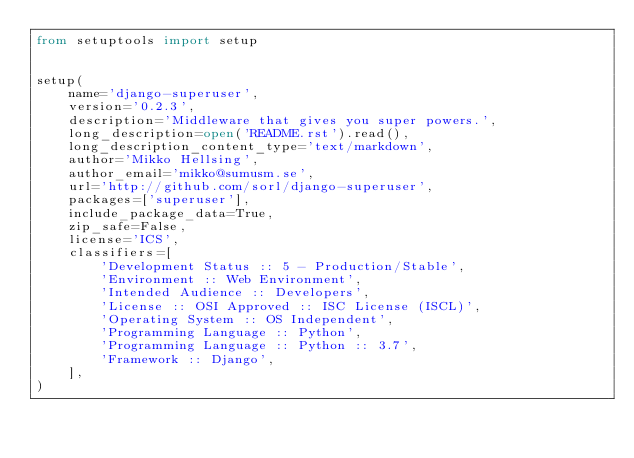Convert code to text. <code><loc_0><loc_0><loc_500><loc_500><_Python_>from setuptools import setup


setup(
    name='django-superuser',
    version='0.2.3',
    description='Middleware that gives you super powers.',
    long_description=open('README.rst').read(),
    long_description_content_type='text/markdown',
    author='Mikko Hellsing',
    author_email='mikko@sumusm.se',
    url='http://github.com/sorl/django-superuser',
    packages=['superuser'],
    include_package_data=True,
    zip_safe=False,
    license='ICS',
    classifiers=[
        'Development Status :: 5 - Production/Stable',
        'Environment :: Web Environment',
        'Intended Audience :: Developers',
        'License :: OSI Approved :: ISC License (ISCL)',
        'Operating System :: OS Independent',
        'Programming Language :: Python',
        'Programming Language :: Python :: 3.7',
        'Framework :: Django',
    ],
)
</code> 